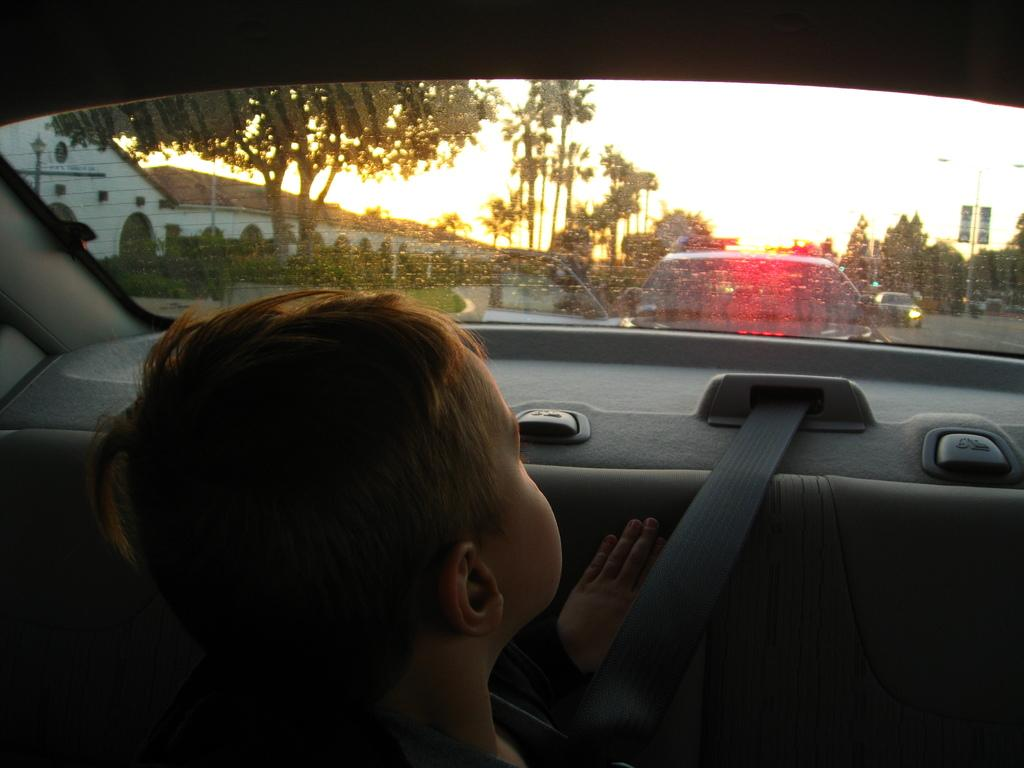What is the boy doing in the image? The boy is sitting inside a car in the image. What is outside the car in the image? There is a road outside the car in the image, and other cars are visible on the road. What can be seen on the right side of the image? There are trees on the right side of the image. What is visible in the background of the image? The sky is visible in the image, and a sunset is depicted. What type of sofa can be seen in the image? There is no sofa present in the image; it features a boy sitting inside a car. How does the sunset twist in the image? The sunset does not twist in the image; it is a natural phenomenon and does not have a twisting motion. 